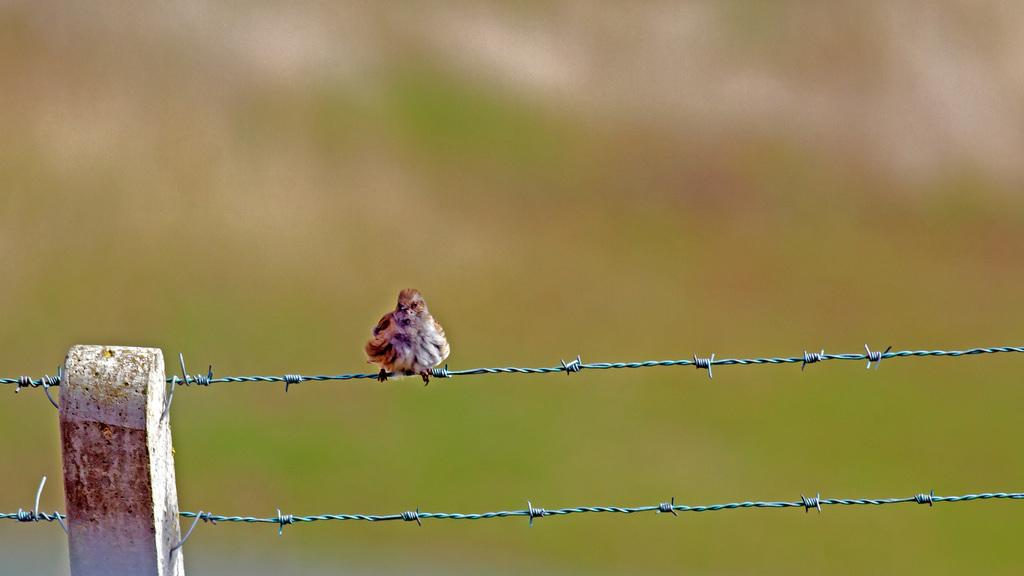What type of animal can be seen in the image? There is a bird in the image. Where is the bird located? The bird is on the fencing. Can you describe the background of the image? The background of the image is blurred. What type of nail is being used by the bird in the image? There is no nail present in the image; the bird is simply perched on the fencing. 